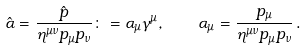<formula> <loc_0><loc_0><loc_500><loc_500>\hat { \alpha } = \frac { \hat { p } } { \eta ^ { \mu \nu } p _ { \mu } p _ { \nu } } \colon = \alpha _ { \mu } \gamma ^ { \mu } , \quad \alpha _ { \mu } = \frac { p _ { \mu } } { \eta ^ { \mu \nu } p _ { \mu } p _ { \nu } } \, .</formula> 